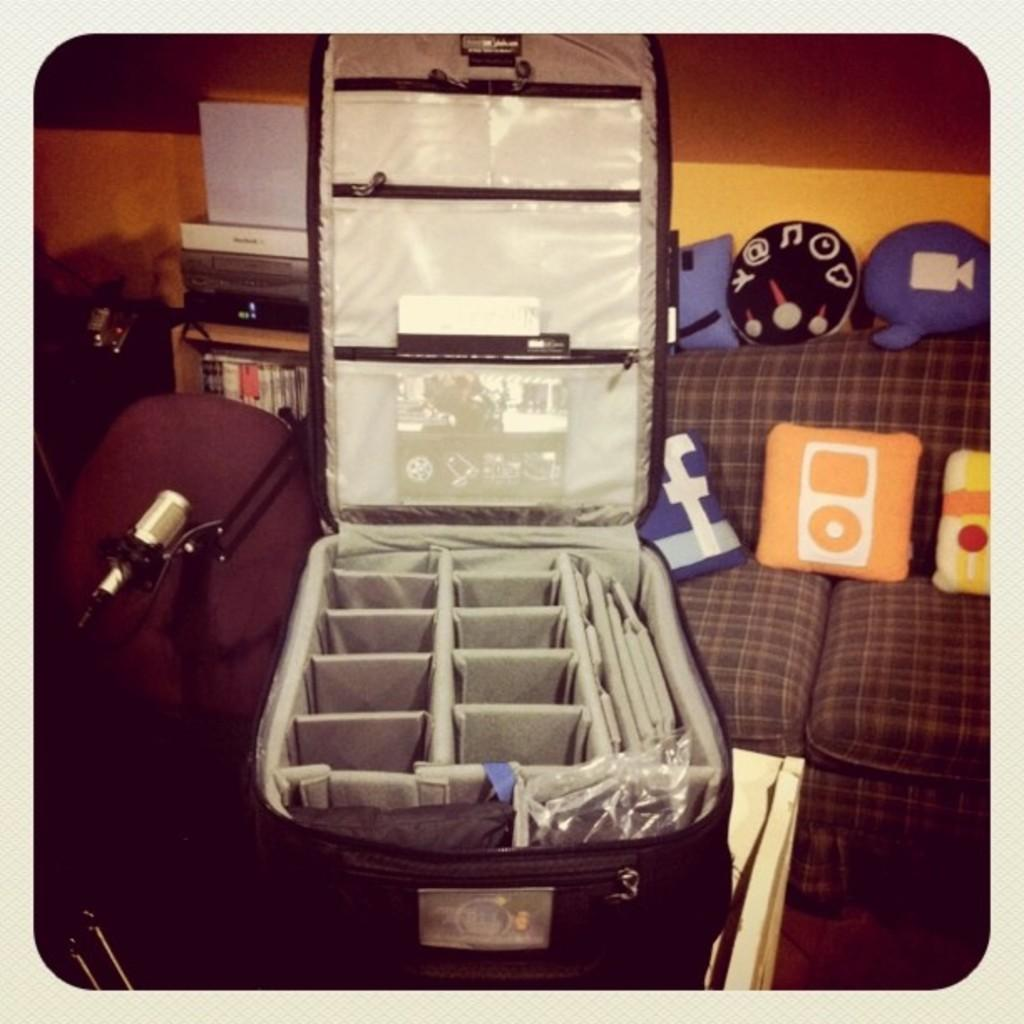What type of furniture is in the image? There is a couch in the image. What is located in front of the couch? There is a table in front of the couch. What food item is on the table? There is a brisket on the table. How many thumbs can be seen touching the brisket in the image? There are no thumbs visible in the image, and therefore no one is touching the brisket. Are there any snails present on the table in the image? There are no snails present on the table in the image. 